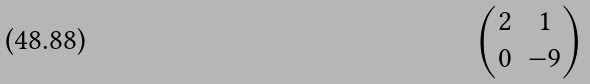<formula> <loc_0><loc_0><loc_500><loc_500>\begin{pmatrix} 2 & 1 \\ 0 & - 9 \end{pmatrix}</formula> 